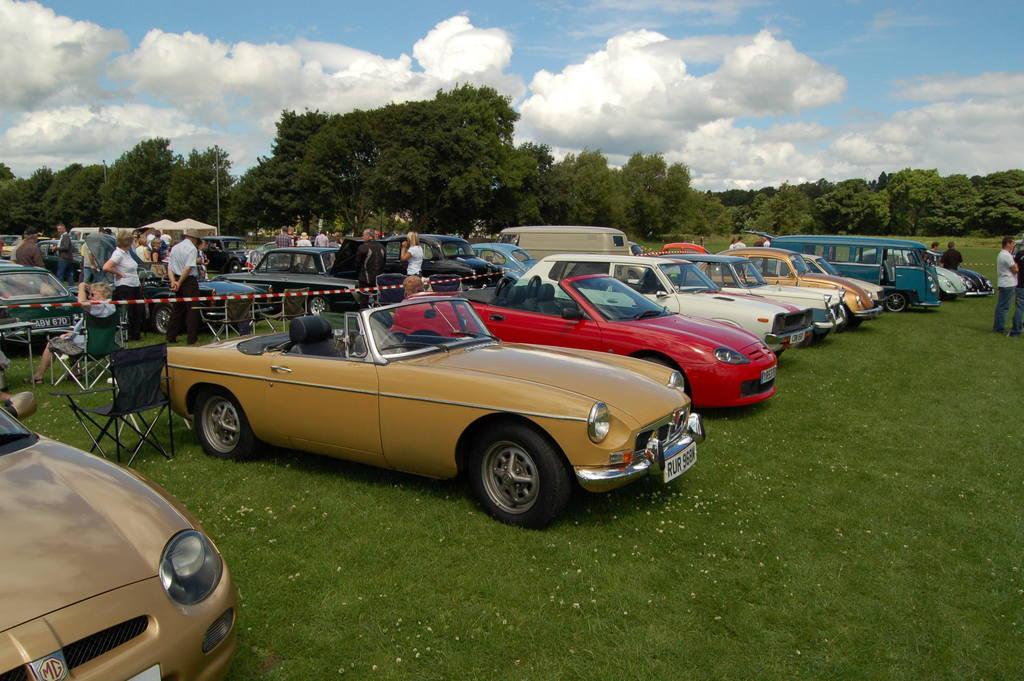Can you describe this image briefly? In this image I can see few vehicles in different colors. I can see few trees, few people and few people are sitting on the chairs. The sky is in white and blue color. 